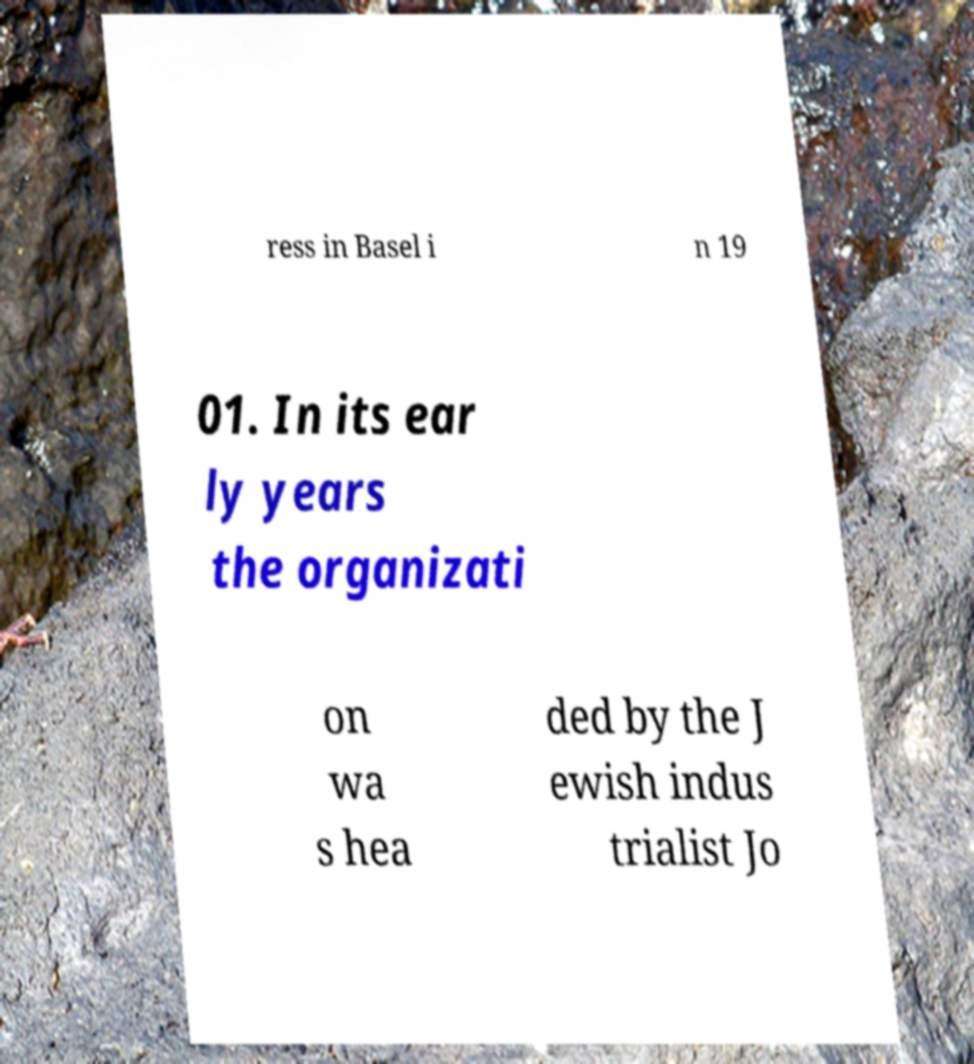Can you accurately transcribe the text from the provided image for me? ress in Basel i n 19 01. In its ear ly years the organizati on wa s hea ded by the J ewish indus trialist Jo 